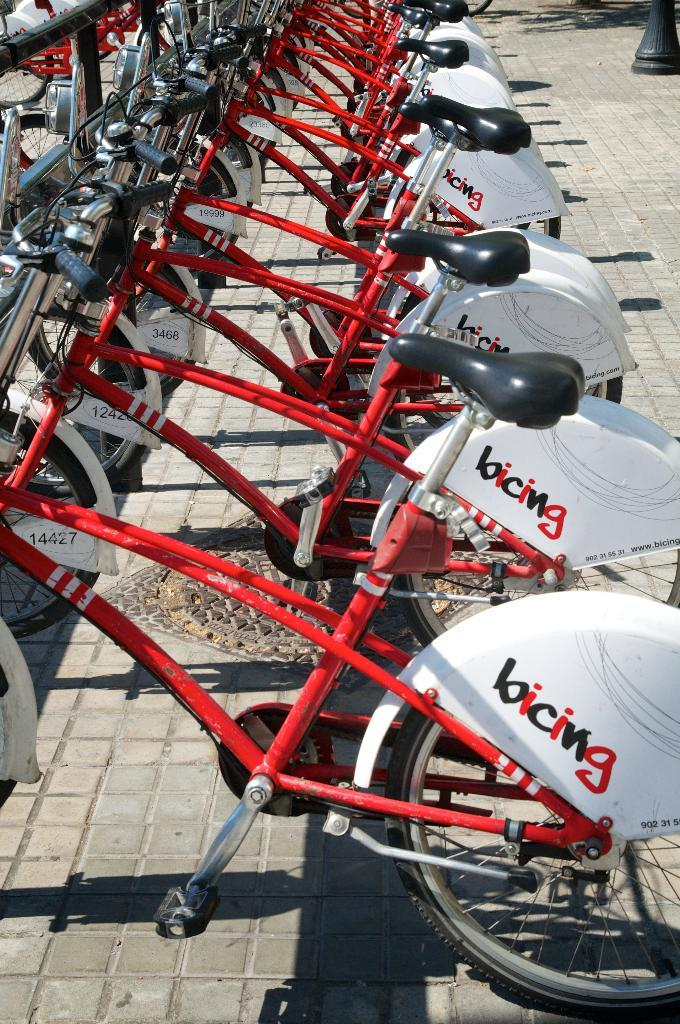What type of vehicles are in the image? There are bicycles in the image. What can be seen beneath the bicycles in the image? The ground is visible in the image. Can you describe the black-colored object with spokes in the top right corner of the image? There is a black-colored object with spokes in the top right corner of the image, but it is not clear what it is from the provided facts. What type of linen is draped over the alley in the image? There is no alley or linen present in the image. What kind of marble is visible on the ground in the image? There is no marble visible on the ground in the image. 